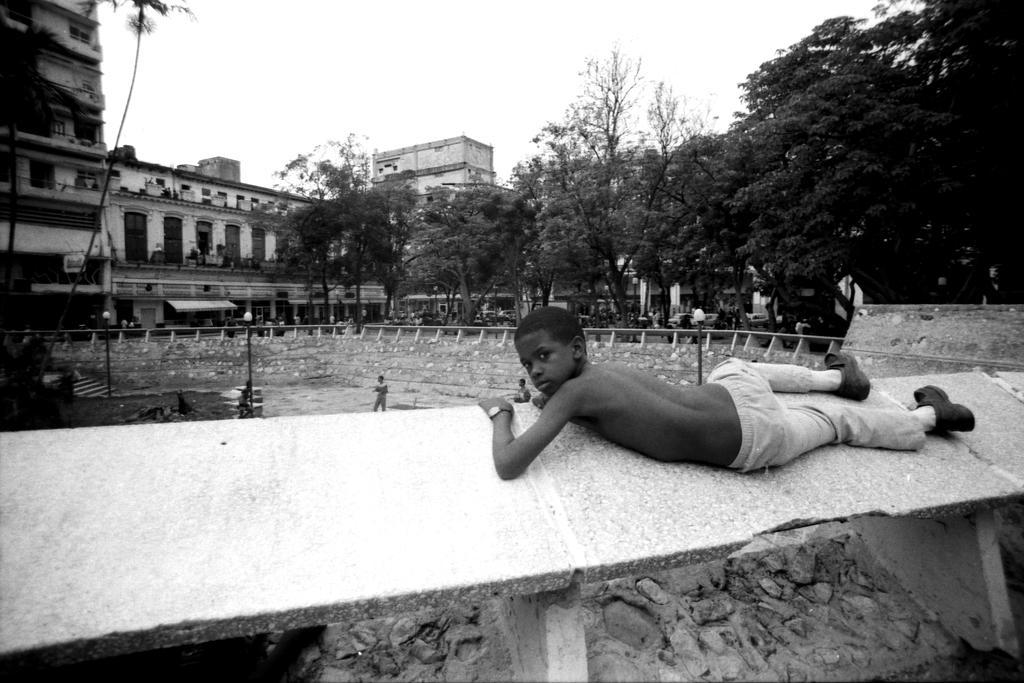How would you summarize this image in a sentence or two? In this picture I can see buildings, trees and few pole lights and I can see few boys on the ground and I can see a boy lying on the wall and I can see sky. 